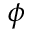Convert formula to latex. <formula><loc_0><loc_0><loc_500><loc_500>\phi</formula> 